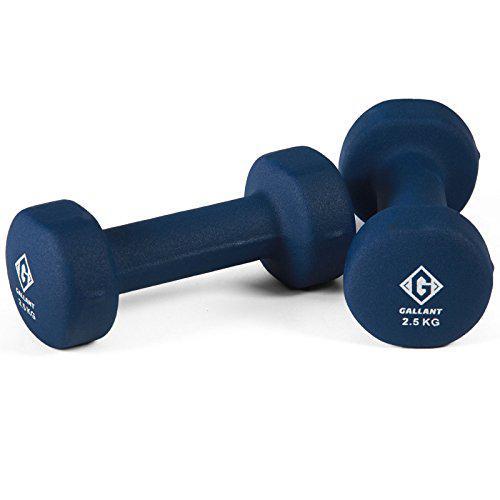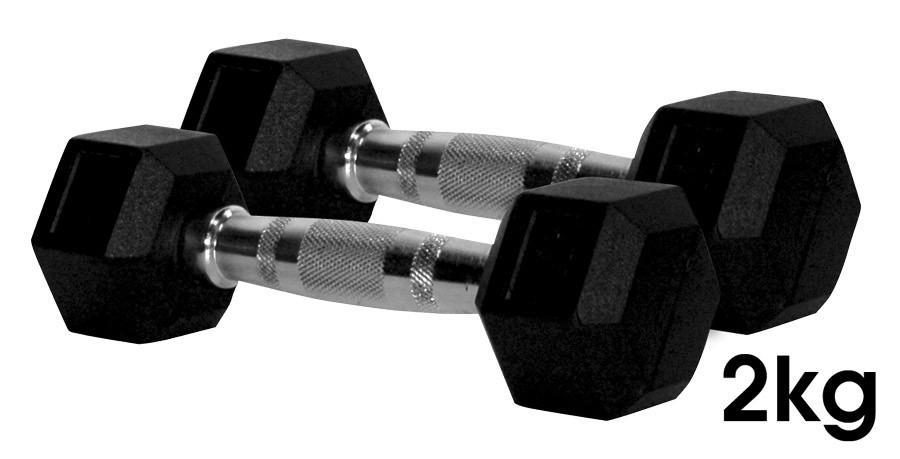The first image is the image on the left, the second image is the image on the right. For the images shown, is this caption "The pair of dumbells in the left image is the same color as the pair of dumbells in the right image." true? Answer yes or no. No. The first image is the image on the left, the second image is the image on the right. Examine the images to the left and right. Is the description "Each image shows two dumbbells, and right and left images show the same color weights." accurate? Answer yes or no. No. 